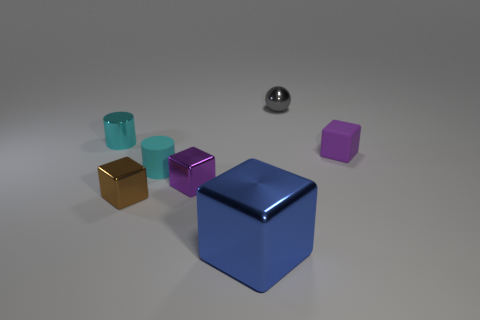What material is the other tiny block that is the same color as the matte block?
Provide a short and direct response. Metal. Are there any tiny metallic cylinders of the same color as the rubber cylinder?
Offer a very short reply. Yes. Is the color of the matte cylinder the same as the object that is to the left of the brown thing?
Your answer should be very brief. Yes. There is another object that is the same shape as the small cyan rubber thing; what size is it?
Offer a very short reply. Small. There is a object that is on the right side of the big object and in front of the gray metal thing; what material is it?
Offer a terse response. Rubber. Is the number of tiny spheres that are in front of the shiny sphere the same as the number of green balls?
Give a very brief answer. Yes. What number of things are either tiny cubes that are on the left side of the gray shiny thing or small brown objects?
Make the answer very short. 2. Does the tiny matte thing that is left of the big blue shiny cube have the same color as the metal cylinder?
Offer a very short reply. Yes. What is the size of the rubber object that is to the right of the small gray ball?
Provide a short and direct response. Small. There is a cyan thing that is behind the cyan cylinder that is right of the metal cylinder; what is its shape?
Provide a succinct answer. Cylinder. 